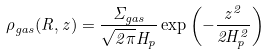<formula> <loc_0><loc_0><loc_500><loc_500>\rho _ { g a s } ( R , z ) = \frac { \Sigma _ { g a s } } { \sqrt { 2 \pi } H _ { p } } \exp \left ( - \frac { z ^ { 2 } } { 2 H _ { p } ^ { 2 } } \right )</formula> 